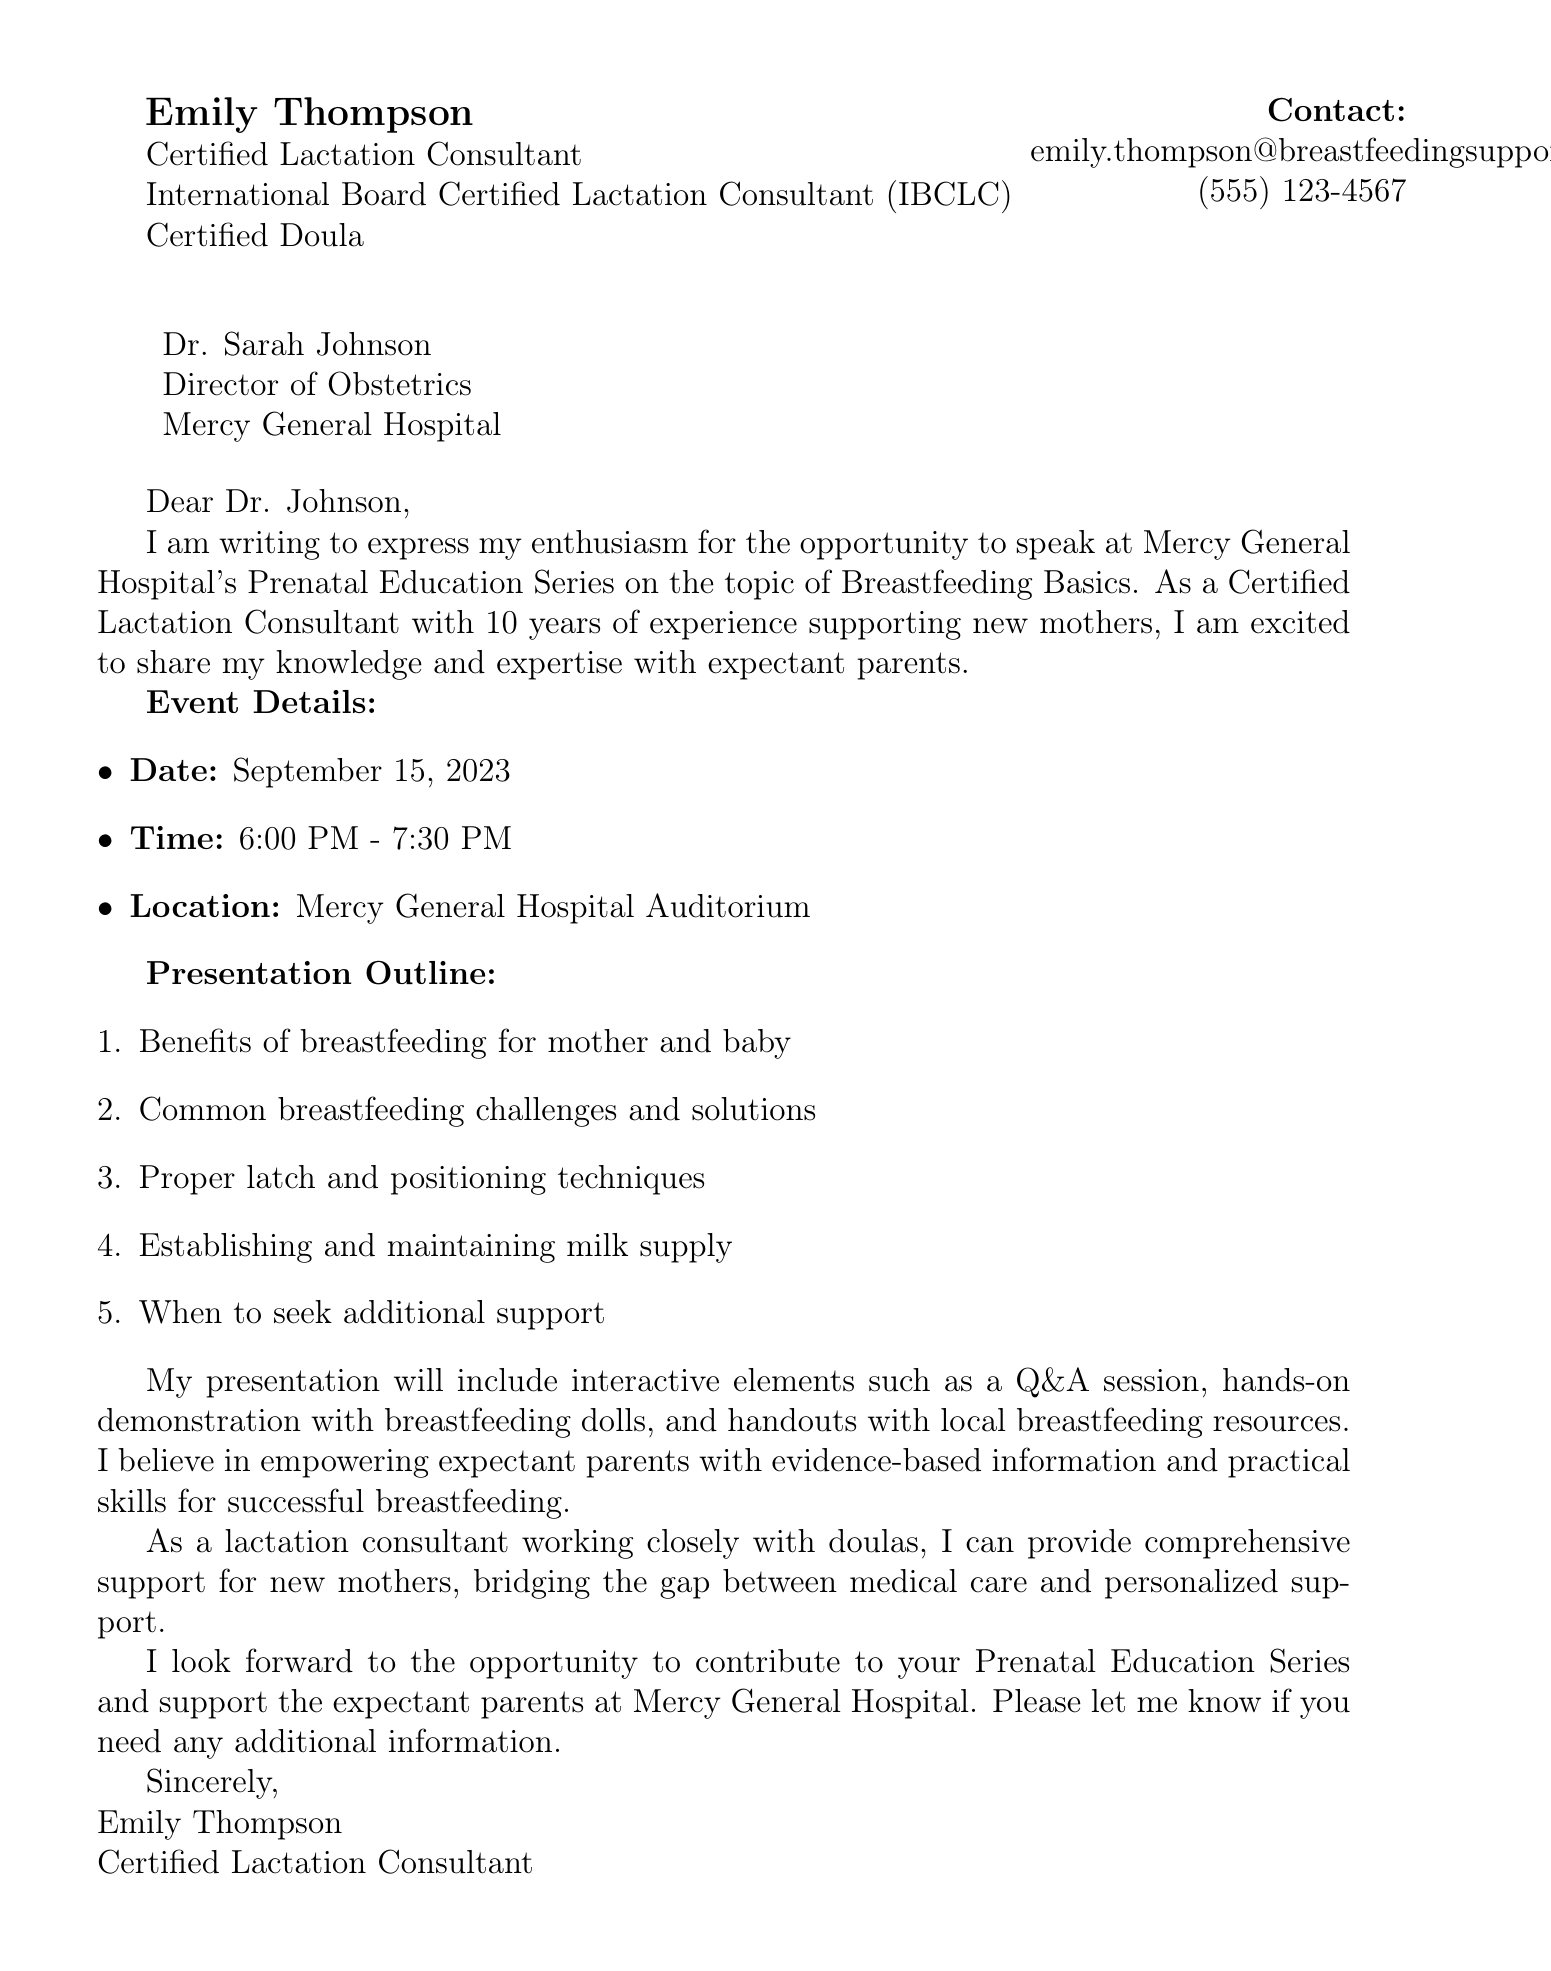What is the name of the speaker? The speaker's name is mentioned in the document as Emily Thompson.
Answer: Emily Thompson What is the date of the event? The document explicitly states that the event will take place on September 15, 2023.
Answer: September 15, 2023 What is the duration of the event? The event is scheduled from 6:00 PM to 7:30 PM, indicating a duration of 1.5 hours.
Answer: 1.5 hours Which hospital is hosting the event? The document specifies that the event is being organized at Mercy General Hospital.
Answer: Mercy General Hospital What is one of the common breastfeeding challenges mentioned in the presentation outline? The presentation outline lists "Common breastfeeding challenges and solutions" as one of the topics to be covered.
Answer: Common breastfeeding challenges and solutions How many years of experience does Emily Thompson have? The document states that Emily Thompson has 10 years of experience supporting new mothers.
Answer: 10 years What type of interactive element will be included? The document mentions a Q&A session as one of the interactive elements included in the presentation.
Answer: Q&A session What is Emily Thompson's contact email? The document provides Emily Thompson's email address for contact.
Answer: emily.thompson@breastfeedingsupport.com What is the value proposition of the presentation? The document describes the value proposition as "Empowering expectant parents with evidence-based information and practical skills for successful breastfeeding."
Answer: Empowering expectant parents with evidence-based information and practical skills for successful breastfeeding 